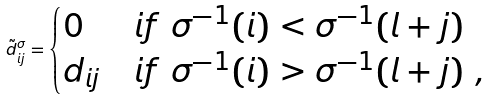Convert formula to latex. <formula><loc_0><loc_0><loc_500><loc_500>\tilde { d } ^ { \sigma } _ { i j } = \begin{cases} 0 & i f \ \sigma ^ { - 1 } ( i ) < \sigma ^ { - 1 } ( l + j ) \\ d _ { i j } & i f \ \sigma ^ { - 1 } ( i ) > \sigma ^ { - 1 } ( l + j ) \ , \end{cases}</formula> 